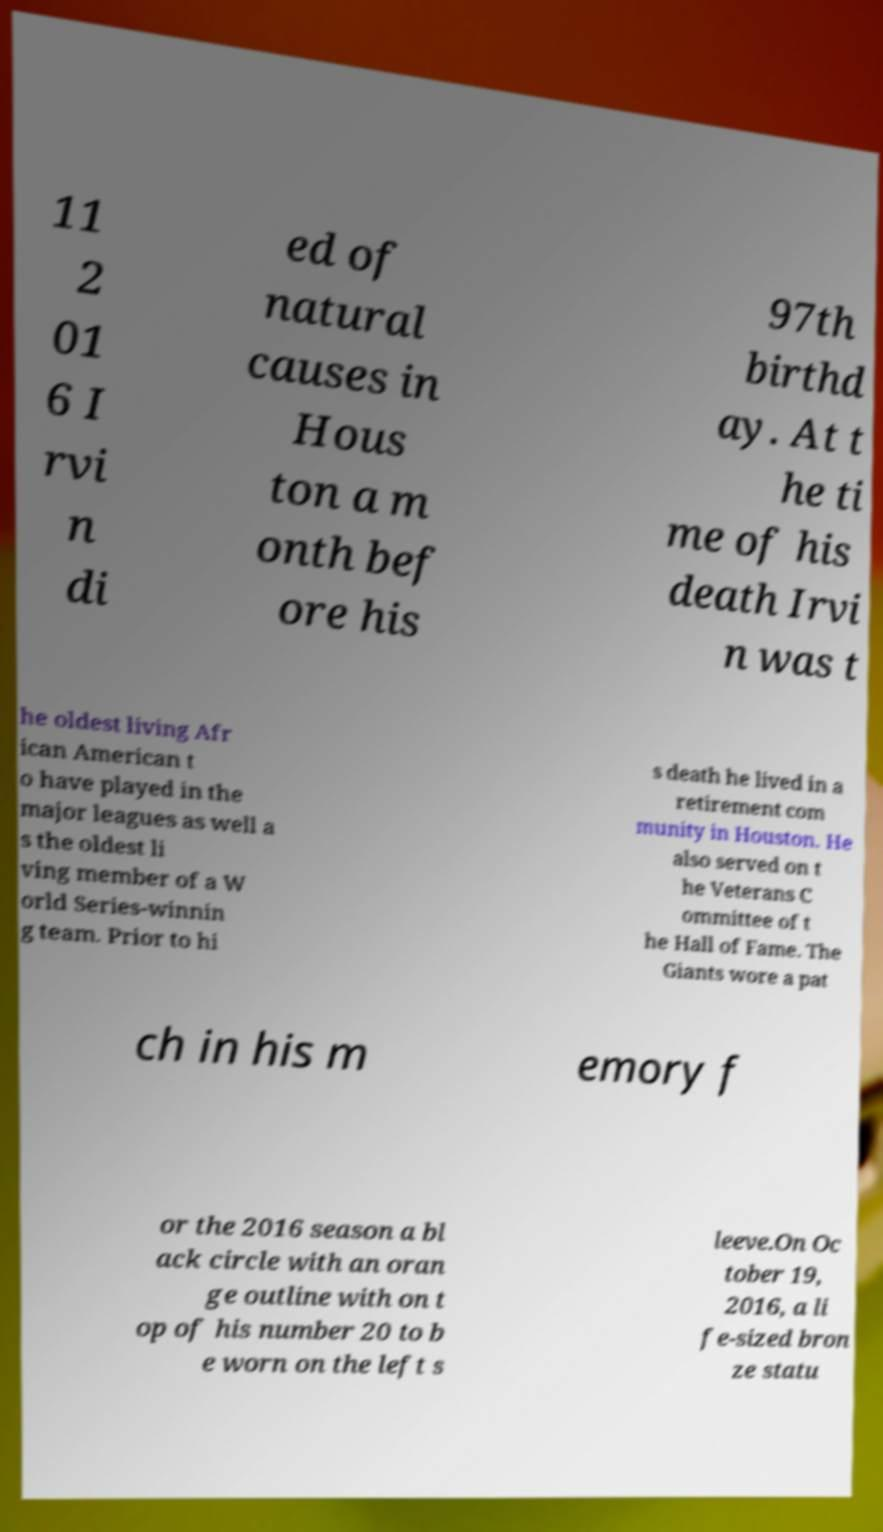I need the written content from this picture converted into text. Can you do that? 11 2 01 6 I rvi n di ed of natural causes in Hous ton a m onth bef ore his 97th birthd ay. At t he ti me of his death Irvi n was t he oldest living Afr ican American t o have played in the major leagues as well a s the oldest li ving member of a W orld Series-winnin g team. Prior to hi s death he lived in a retirement com munity in Houston. He also served on t he Veterans C ommittee of t he Hall of Fame. The Giants wore a pat ch in his m emory f or the 2016 season a bl ack circle with an oran ge outline with on t op of his number 20 to b e worn on the left s leeve.On Oc tober 19, 2016, a li fe-sized bron ze statu 